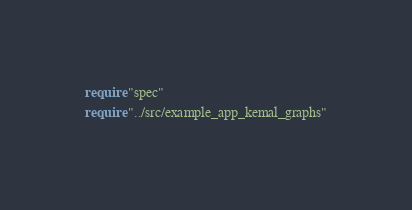Convert code to text. <code><loc_0><loc_0><loc_500><loc_500><_Crystal_>require "spec"
require "../src/example_app_kemal_graphs"
</code> 